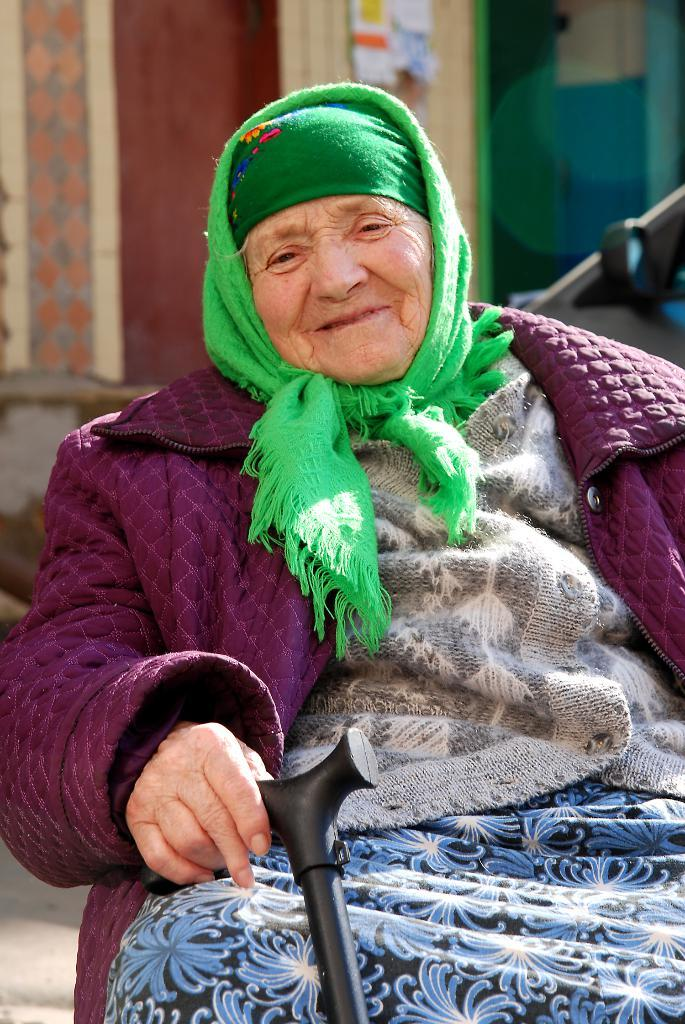What is the main subject of the image? There is a woman in the image. Can you describe the woman's attire? The woman is wearing a dress and a cap. What is the woman holding in her hand? The woman is holding a stick in her hand. What can be seen in the background of the image? There is a building and a vehicle in the background of the image. What is the woman's opinion on the dirt in the image? There is no dirt present in the image, so it is not possible to determine the woman's opinion on it. 